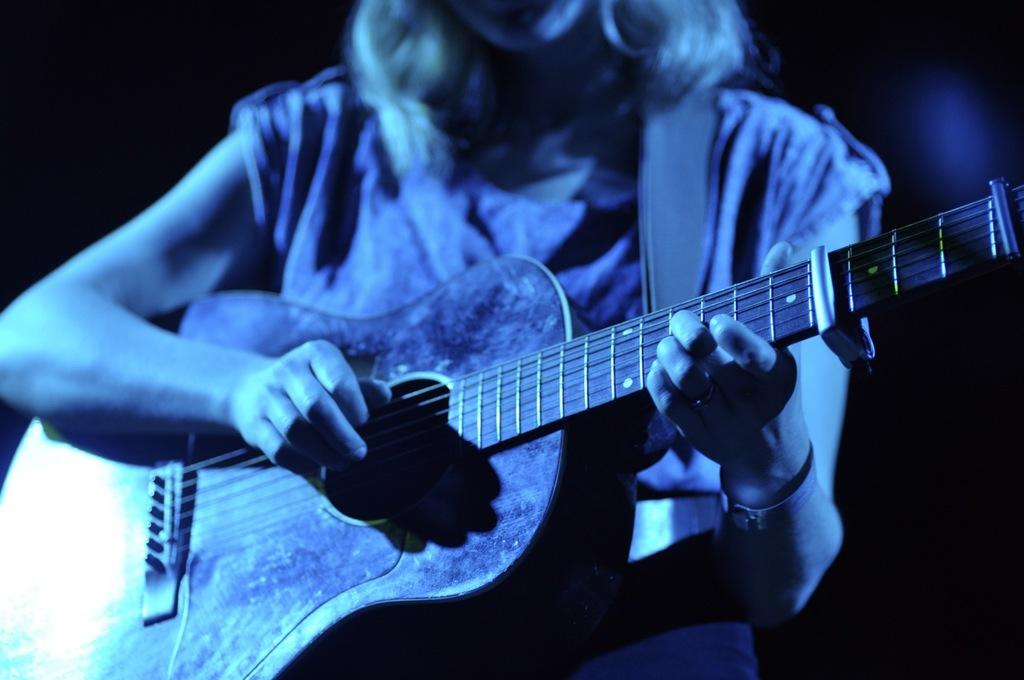Who is the main subject in the image? There is a woman in the image. What is the woman doing in the image? The woman is playing a guitar. How many sponges are visible in the image? There are no sponges visible in the image. What type of balls can be seen being juggled by the woman in the image? There are no balls or juggling activity depicted in the image; the woman is playing a guitar. 